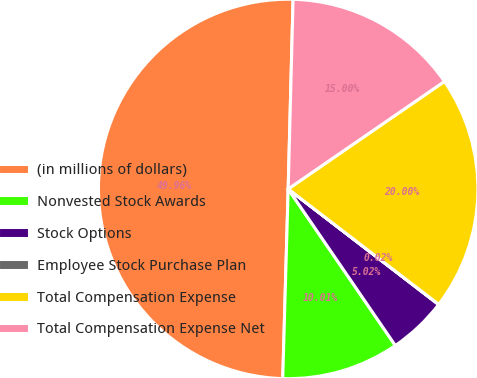<chart> <loc_0><loc_0><loc_500><loc_500><pie_chart><fcel>(in millions of dollars)<fcel>Nonvested Stock Awards<fcel>Stock Options<fcel>Employee Stock Purchase Plan<fcel>Total Compensation Expense<fcel>Total Compensation Expense Net<nl><fcel>49.96%<fcel>10.01%<fcel>5.02%<fcel>0.02%<fcel>20.0%<fcel>15.0%<nl></chart> 